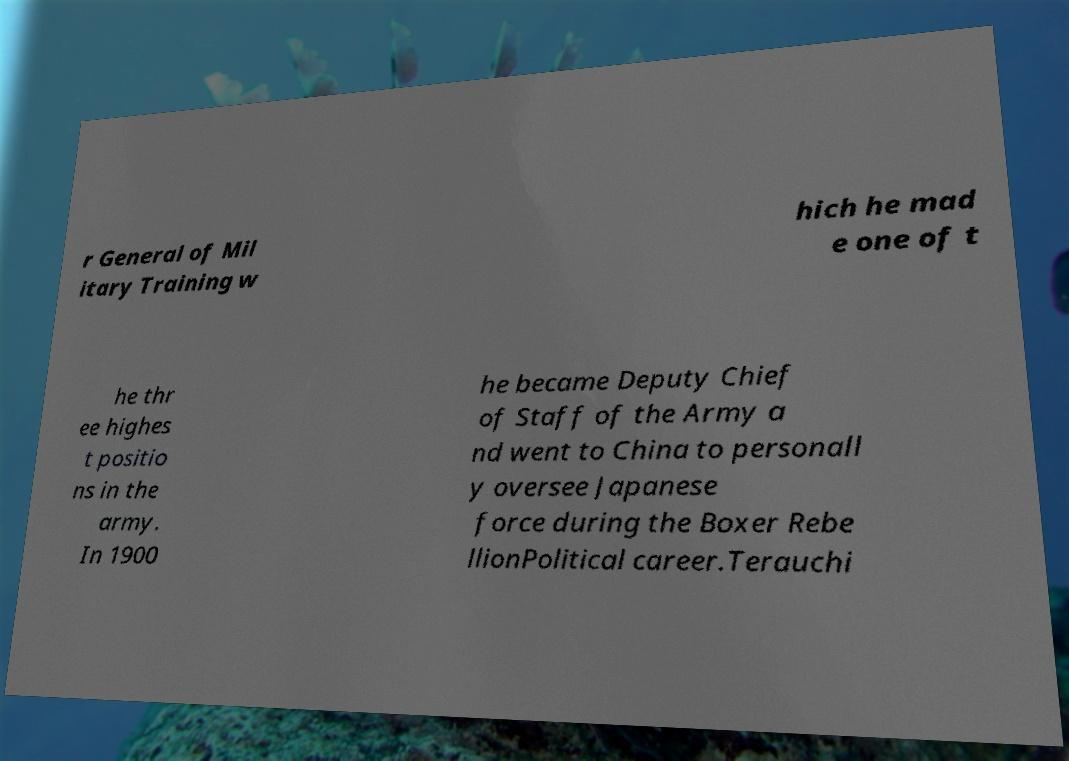Could you extract and type out the text from this image? r General of Mil itary Training w hich he mad e one of t he thr ee highes t positio ns in the army. In 1900 he became Deputy Chief of Staff of the Army a nd went to China to personall y oversee Japanese force during the Boxer Rebe llionPolitical career.Terauchi 